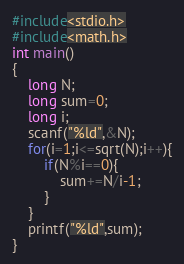<code> <loc_0><loc_0><loc_500><loc_500><_C_>#include<stdio.h>
#include<math.h>
int main()
{
	long N;
	long sum=0;
	long i;
	scanf("%ld",&N);
	for(i=1;i<=sqrt(N);i++){
		if(N%i==0){
			sum+=N/i-1;
		}
	}
	printf("%ld",sum);
}</code> 